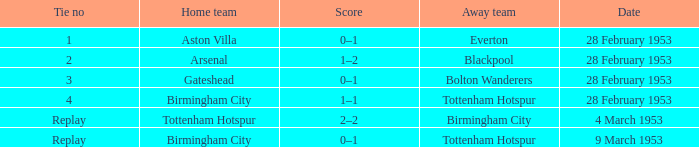What score is associated with the date february 28, 1953, and has a tie number of 3? 0–1. 